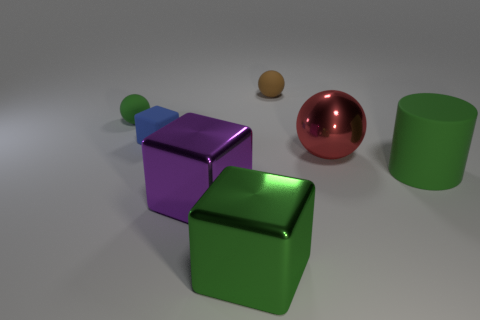There is a shiny block in front of the big purple shiny cube; is its color the same as the small sphere to the left of the green metallic cube?
Your answer should be compact. Yes. There is a matte object that is the same size as the red metallic thing; what color is it?
Your response must be concise. Green. Is there a block that has the same color as the cylinder?
Make the answer very short. Yes. Does the rubber ball on the left side of the matte cube have the same size as the tiny brown rubber sphere?
Your answer should be very brief. Yes. Are there an equal number of red spheres behind the big red ball and blue shiny cylinders?
Make the answer very short. Yes. How many objects are either small blue things behind the big matte object or tiny brown things?
Provide a short and direct response. 2. The thing that is in front of the tiny green matte thing and behind the big red thing has what shape?
Offer a very short reply. Cube. How many things are green matte things behind the big red sphere or objects in front of the shiny ball?
Provide a short and direct response. 4. How many other objects are there of the same size as the blue matte cube?
Make the answer very short. 2. There is a small rubber ball on the left side of the green shiny object; does it have the same color as the rubber cylinder?
Your response must be concise. Yes. 